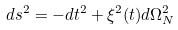<formula> <loc_0><loc_0><loc_500><loc_500>d s ^ { 2 } = - d t ^ { 2 } + \xi ^ { 2 } ( t ) d \Omega _ { N } ^ { 2 }</formula> 